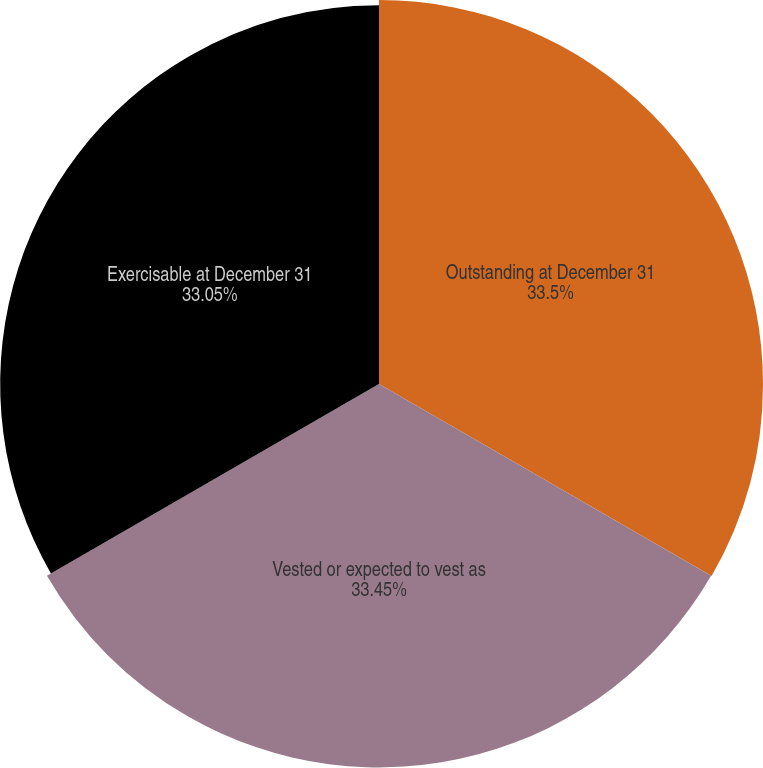Convert chart to OTSL. <chart><loc_0><loc_0><loc_500><loc_500><pie_chart><fcel>Outstanding at December 31<fcel>Vested or expected to vest as<fcel>Exercisable at December 31<nl><fcel>33.5%<fcel>33.45%<fcel>33.05%<nl></chart> 